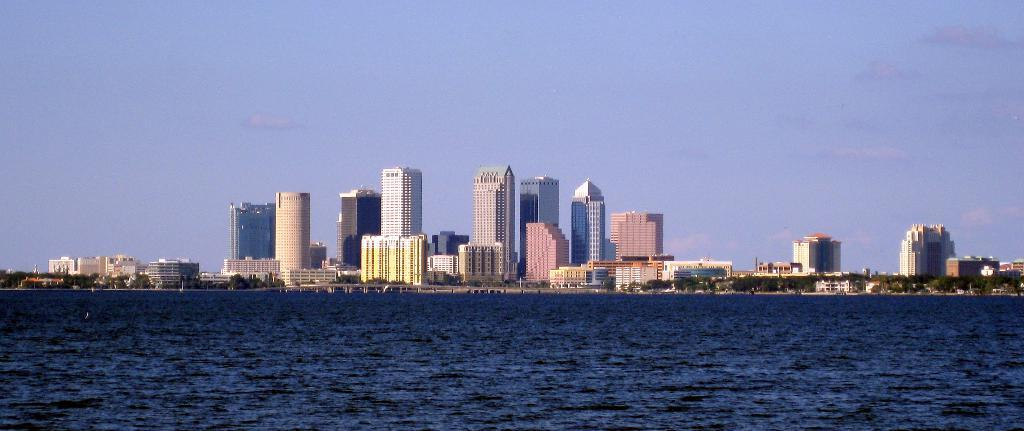What type of natural environment is depicted in the image? There is a sea in the image. What type of man-made structures can be seen in the image? There are buildings and houses in the image. What type of vegetation is present in the image? There are trees and plants in the image. What type of oven can be seen in the image? There is no oven present in the image. What type of stone is visible in the image? There is no stone visible in the image. 